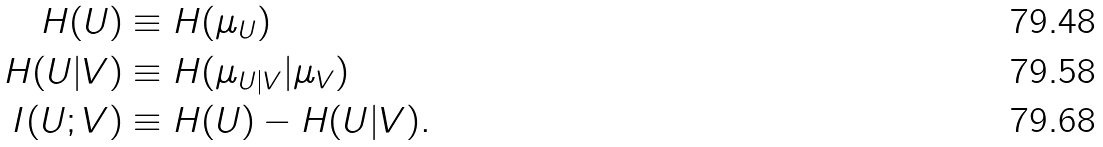Convert formula to latex. <formula><loc_0><loc_0><loc_500><loc_500>H ( U ) & \equiv H ( \mu _ { U } ) \\ H ( U | V ) & \equiv H ( \mu _ { U | V } | \mu _ { V } ) \\ I ( U ; V ) & \equiv H ( U ) - H ( U | V ) .</formula> 